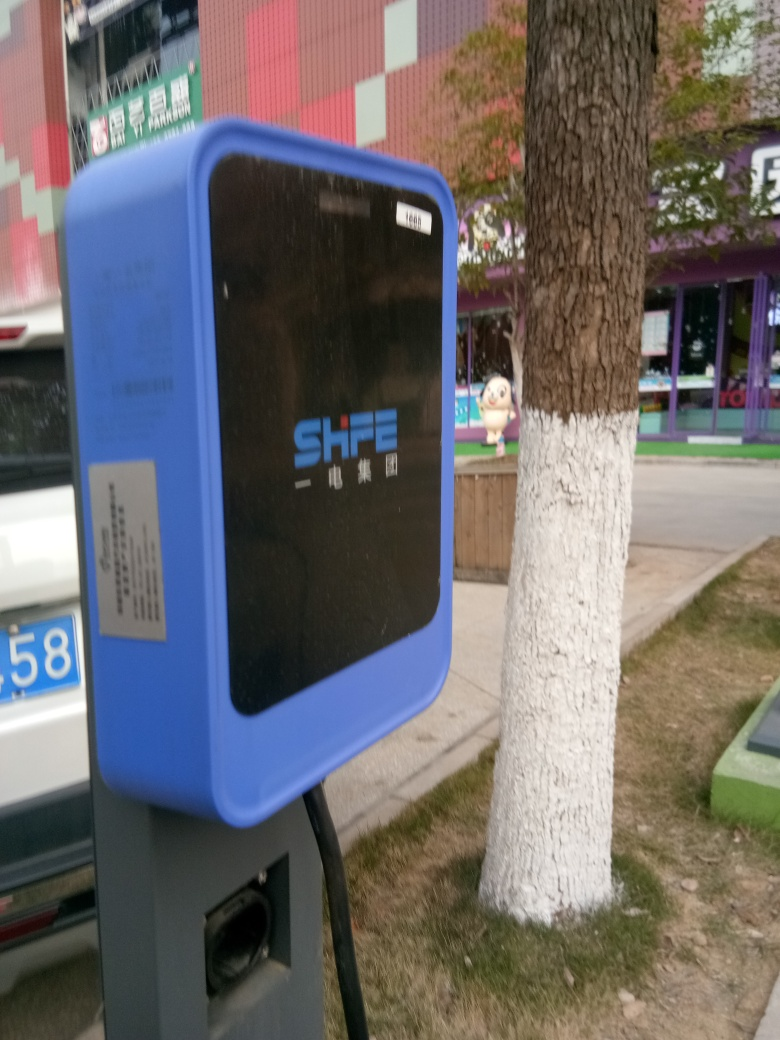What's the focal point of this image? The focal point of the image appears to be the electric vehicle (EV) charging station in the foreground, which is sharp and clear compared to the background. Can you tell me more about EV charging stations? Electric Vehicle charging stations are infrastructure elements that offer power supply for recharging electric cars. These stations provide convenient charging solutions and can vary in charging speed and compatibility with different vehicle models. 